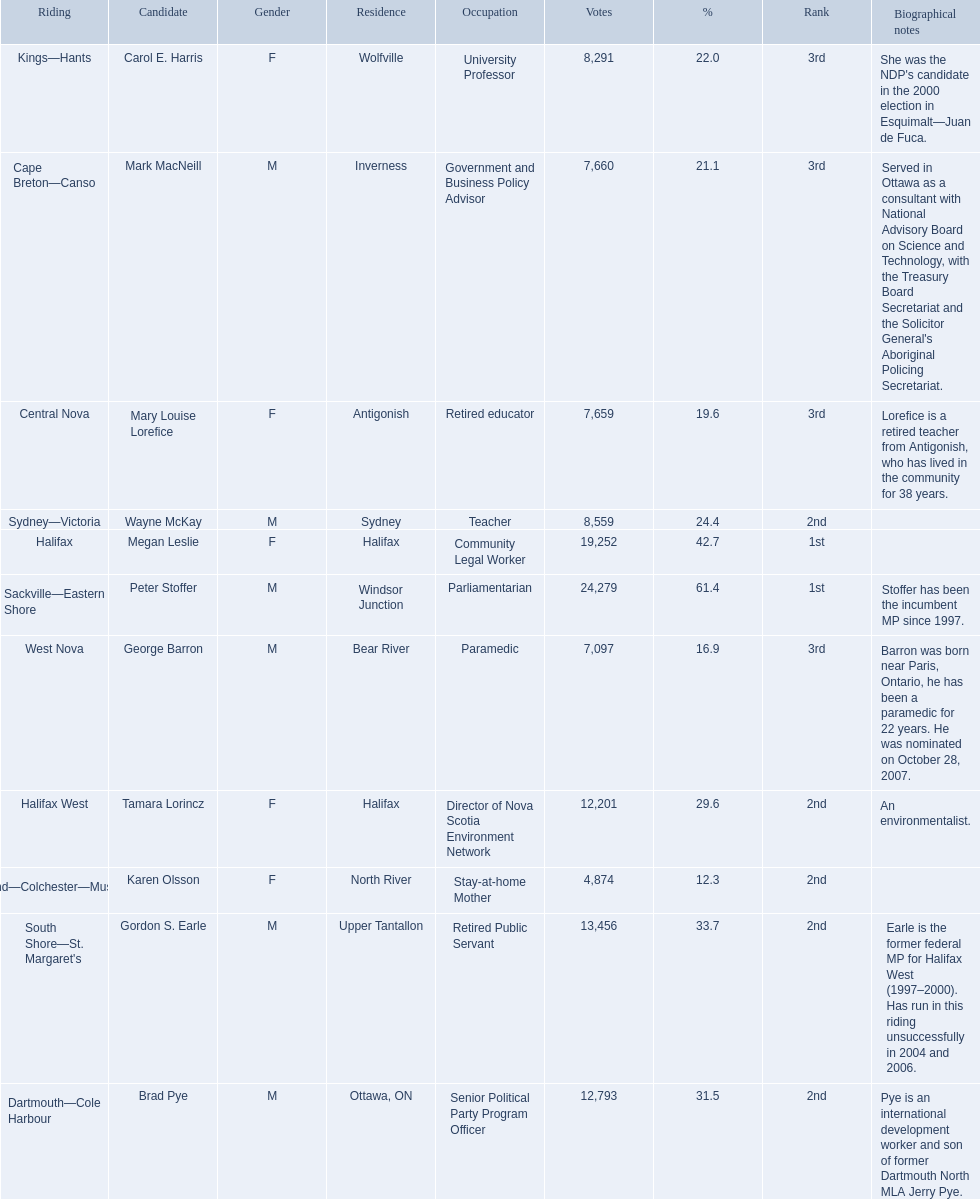Who are all the candidates? Mark MacNeill, Mary Louise Lorefice, Karen Olsson, Brad Pye, Megan Leslie, Tamara Lorincz, Carol E. Harris, Peter Stoffer, Gordon S. Earle, Wayne McKay, George Barron. How many votes did they receive? 7,660, 7,659, 4,874, 12,793, 19,252, 12,201, 8,291, 24,279, 13,456, 8,559, 7,097. And of those, how many were for megan leslie? 19,252. 